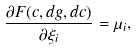Convert formula to latex. <formula><loc_0><loc_0><loc_500><loc_500>\frac { \partial F ( c , d { g } , d c ) } { \partial \xi _ { i } } = \mu _ { i } ,</formula> 